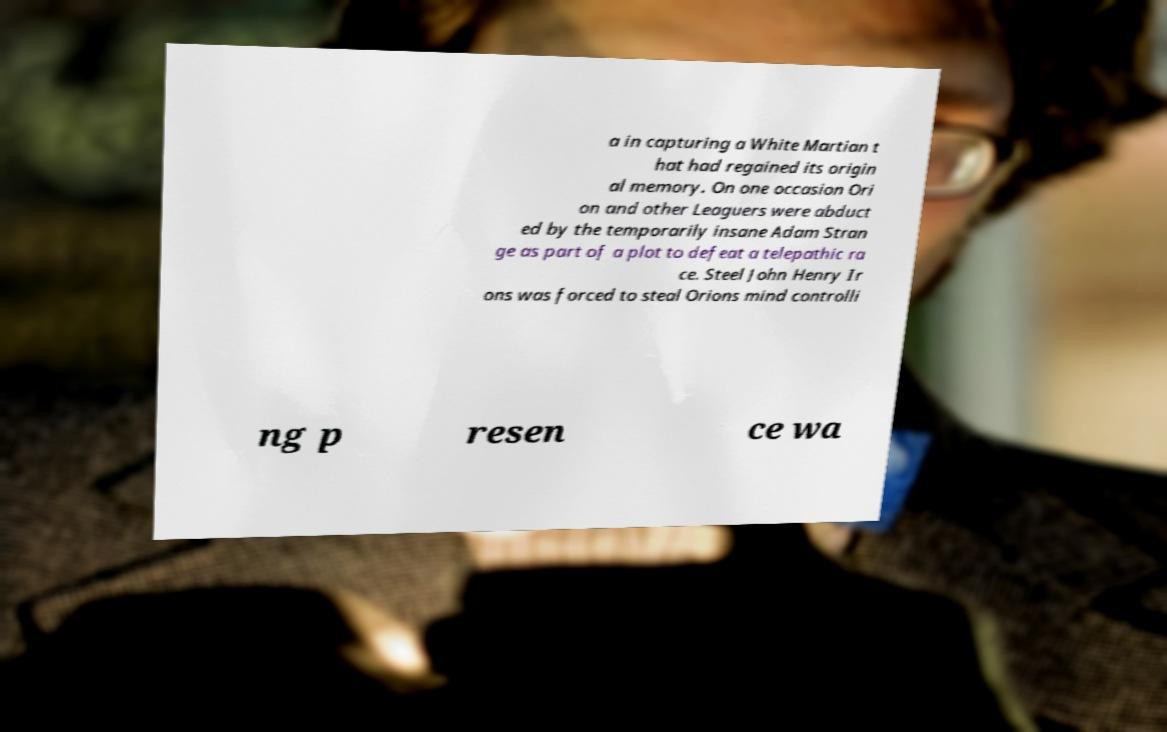Could you assist in decoding the text presented in this image and type it out clearly? a in capturing a White Martian t hat had regained its origin al memory. On one occasion Ori on and other Leaguers were abduct ed by the temporarily insane Adam Stran ge as part of a plot to defeat a telepathic ra ce. Steel John Henry Ir ons was forced to steal Orions mind controlli ng p resen ce wa 